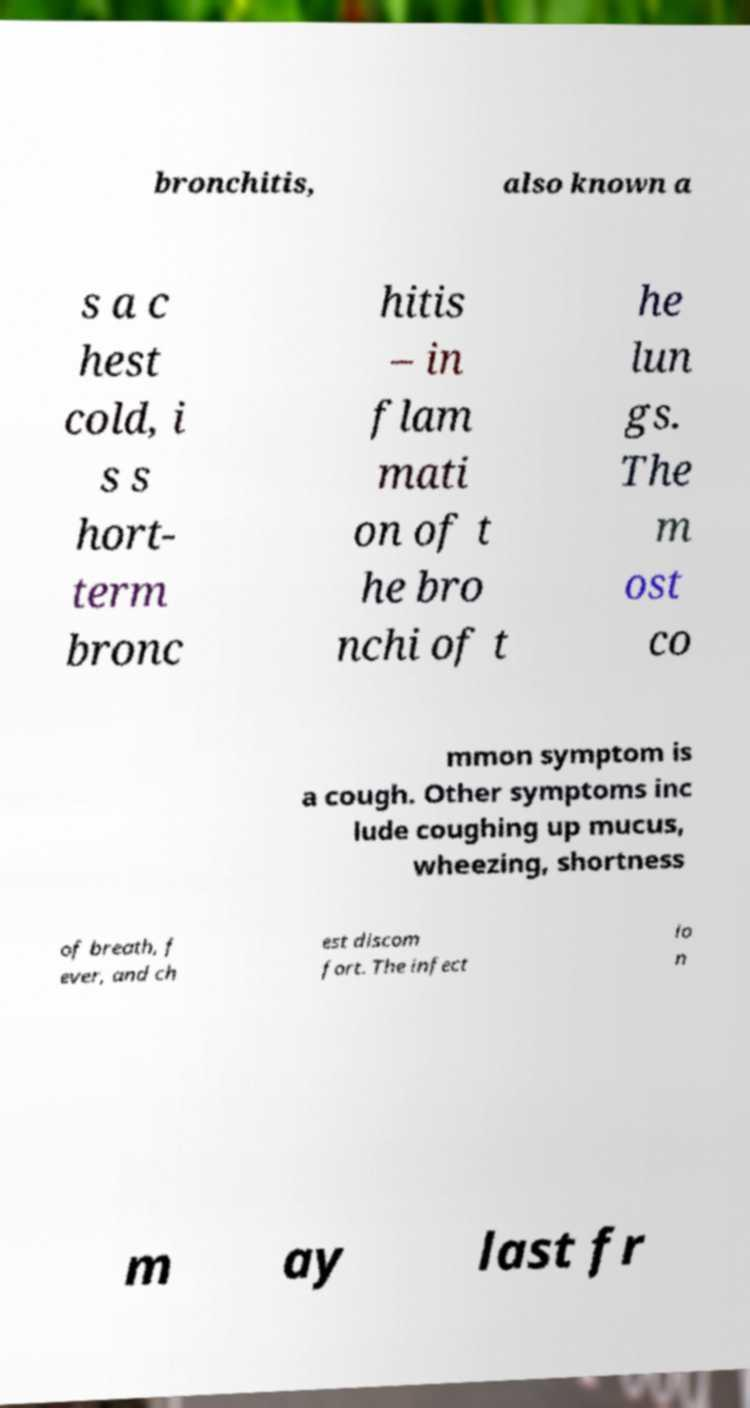Could you extract and type out the text from this image? bronchitis, also known a s a c hest cold, i s s hort- term bronc hitis – in flam mati on of t he bro nchi of t he lun gs. The m ost co mmon symptom is a cough. Other symptoms inc lude coughing up mucus, wheezing, shortness of breath, f ever, and ch est discom fort. The infect io n m ay last fr 